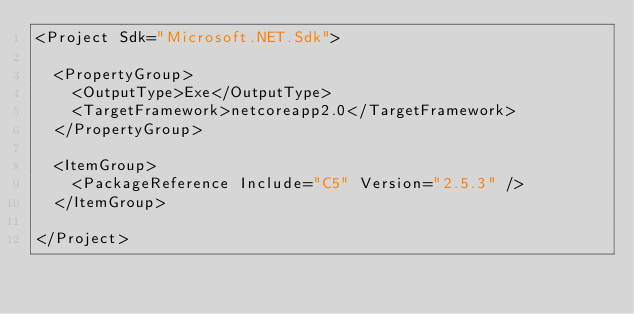Convert code to text. <code><loc_0><loc_0><loc_500><loc_500><_XML_><Project Sdk="Microsoft.NET.Sdk">

  <PropertyGroup>
    <OutputType>Exe</OutputType>
    <TargetFramework>netcoreapp2.0</TargetFramework>
  </PropertyGroup>

  <ItemGroup>
    <PackageReference Include="C5" Version="2.5.3" />
  </ItemGroup>

</Project>
</code> 